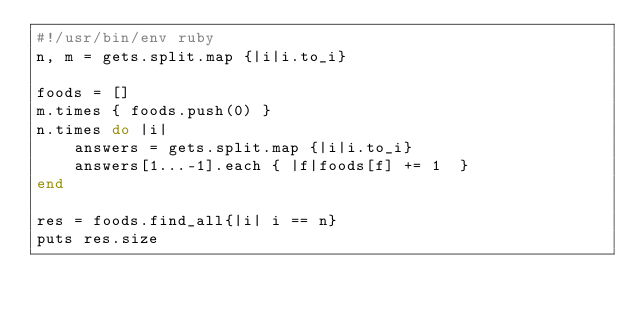<code> <loc_0><loc_0><loc_500><loc_500><_Ruby_>#!/usr/bin/env ruby
n, m = gets.split.map {|i|i.to_i}

foods = []
m.times { foods.push(0) }
n.times do |i|
    answers = gets.split.map {|i|i.to_i}
    answers[1...-1].each { |f|foods[f] += 1  }
end

res = foods.find_all{|i| i == n}
puts res.size</code> 